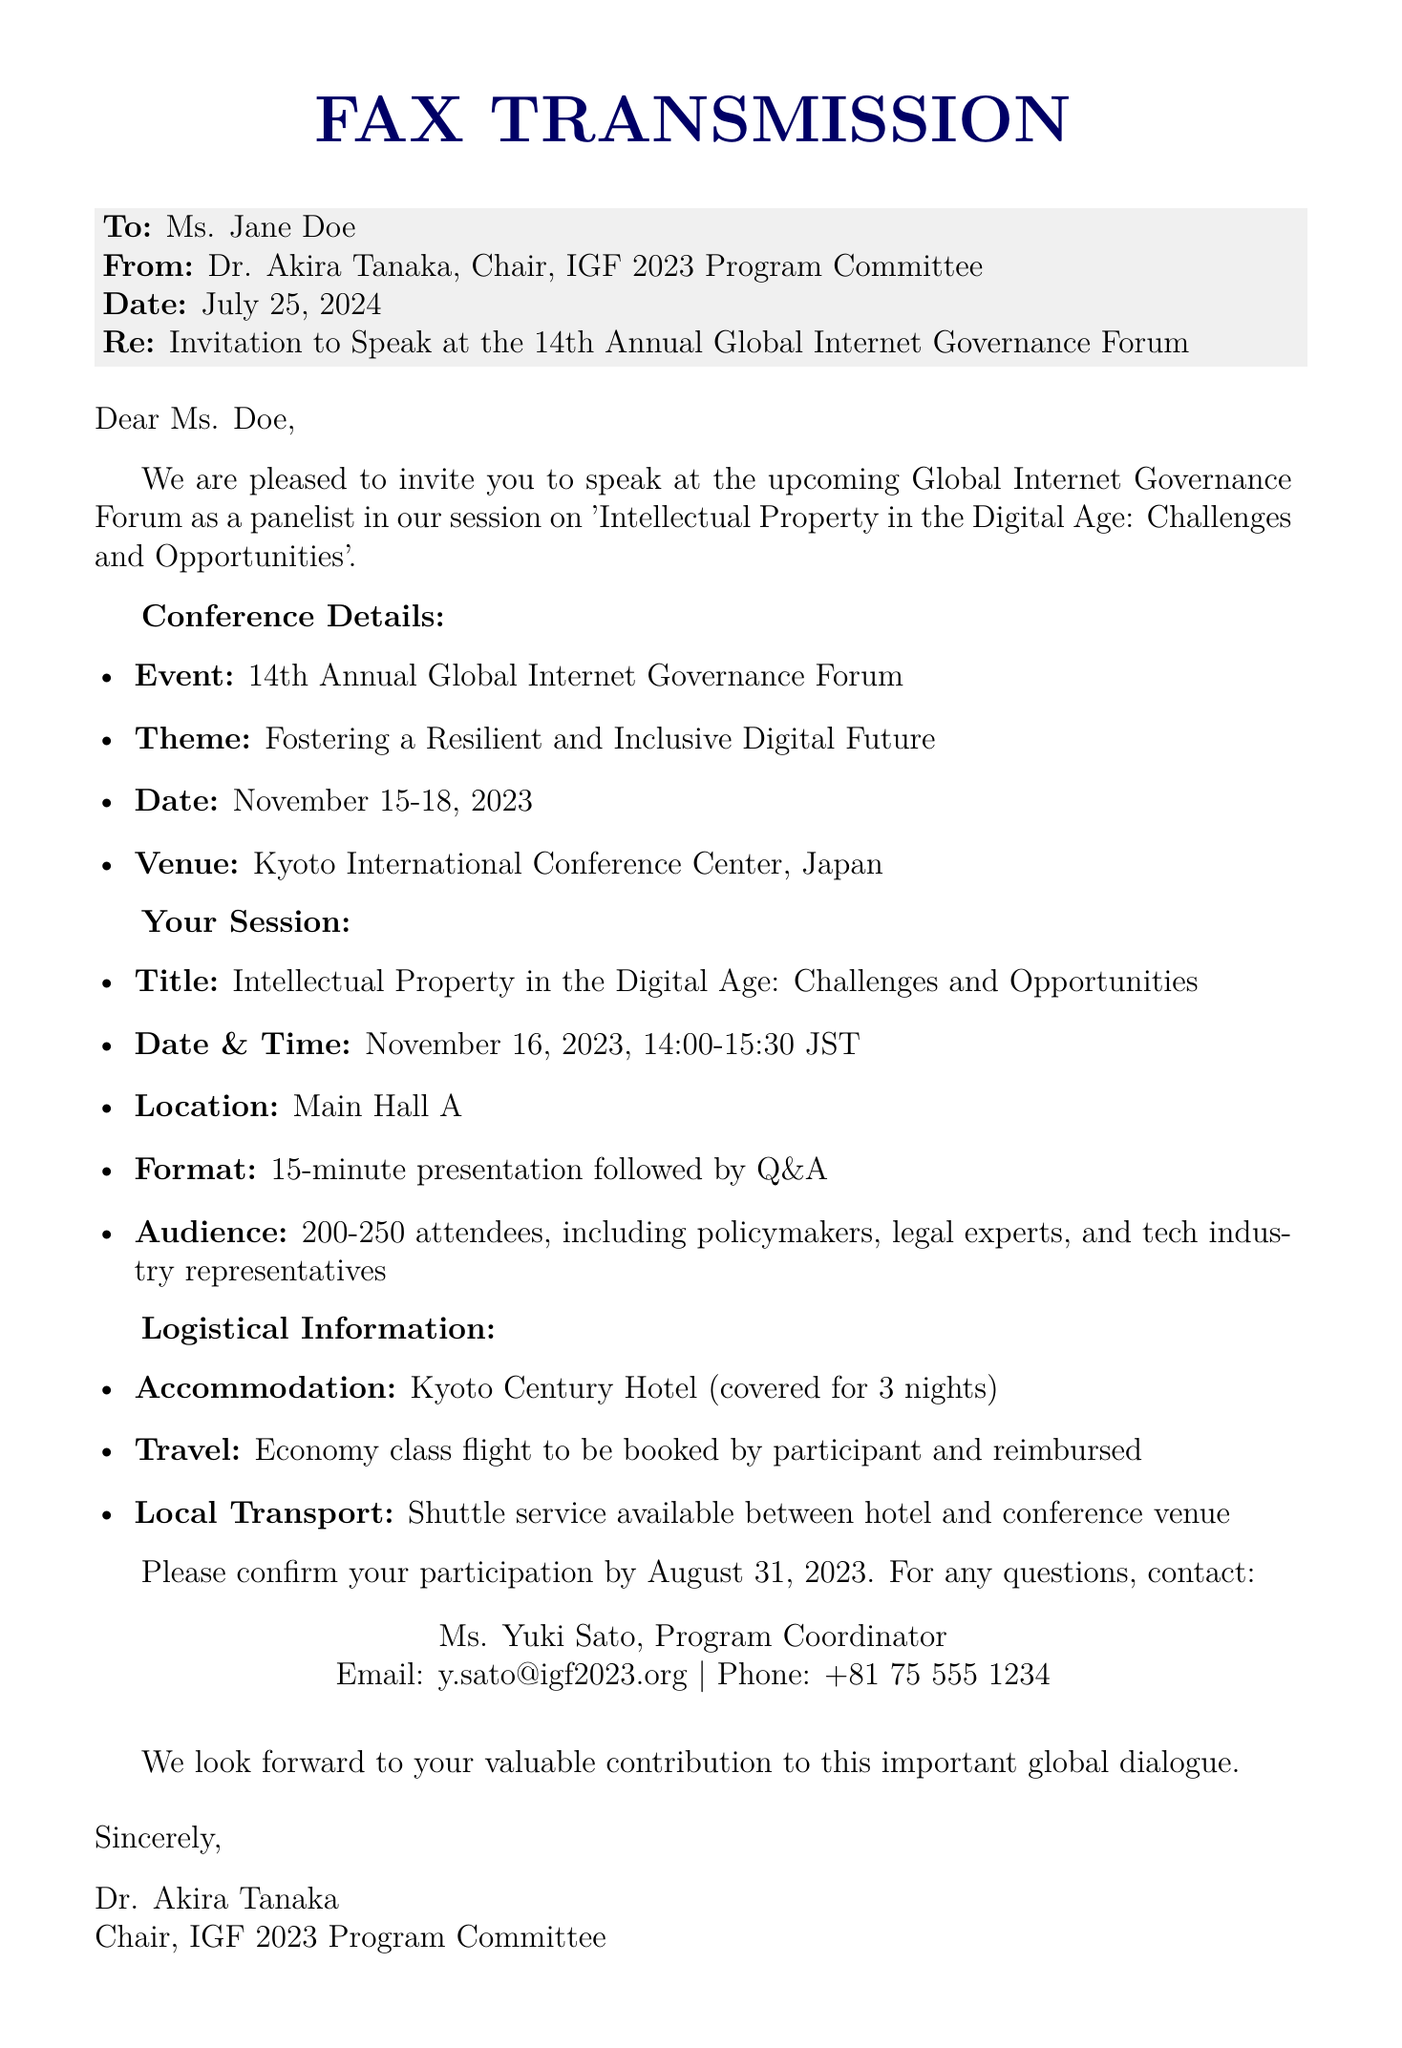What is the name of the event? The name of the event is provided in the document and is the "14th Annual Global Internet Governance Forum."
Answer: 14th Annual Global Internet Governance Forum Who is the sender of the fax? The sender of the fax is mentioned in the document, and it is Dr. Akira Tanaka, the Chair of the IGF 2023 Program Committee.
Answer: Dr. Akira Tanaka When is the session on Intellectual Property scheduled? The date and time for the session are clearly stated in the document as November 16, 2023, from 14:00 to 15:30 JST.
Answer: November 16, 2023, 14:00-15:30 JST What is covered for accommodation? The document specifies the accommodation details, stating that the Kyoto Century Hotel is covered for three nights.
Answer: Covered for 3 nights How should the travel expenses be managed? The document indicates the travel arrangement, specifying that the economy class flight should be booked by the participant and reimbursed later.
Answer: Booked by participant and reimbursed What is the main theme of the conference? The theme of the conference is highlighted in the document, which is "Fostering a Resilient and Inclusive Digital Future."
Answer: Fostering a Resilient and Inclusive Digital Future How many attendees are expected in the session? The anticipated number of attendees is stated in the document, indicating an audience of 200-250 people.
Answer: 200-250 attendees 